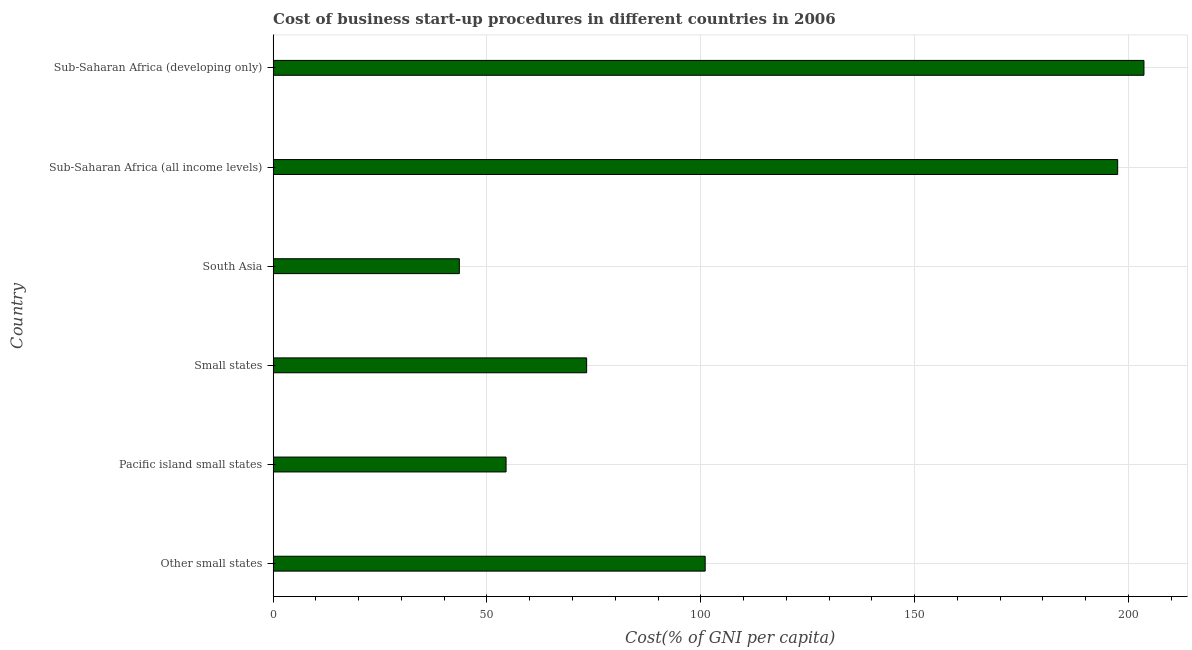Does the graph contain any zero values?
Offer a very short reply. No. What is the title of the graph?
Provide a succinct answer. Cost of business start-up procedures in different countries in 2006. What is the label or title of the X-axis?
Keep it short and to the point. Cost(% of GNI per capita). What is the label or title of the Y-axis?
Your answer should be very brief. Country. What is the cost of business startup procedures in Sub-Saharan Africa (all income levels)?
Your response must be concise. 197.47. Across all countries, what is the maximum cost of business startup procedures?
Give a very brief answer. 203.61. Across all countries, what is the minimum cost of business startup procedures?
Your answer should be compact. 43.54. In which country was the cost of business startup procedures maximum?
Give a very brief answer. Sub-Saharan Africa (developing only). In which country was the cost of business startup procedures minimum?
Offer a very short reply. South Asia. What is the sum of the cost of business startup procedures?
Give a very brief answer. 673.41. What is the difference between the cost of business startup procedures in Pacific island small states and Small states?
Ensure brevity in your answer.  -18.84. What is the average cost of business startup procedures per country?
Provide a short and direct response. 112.24. What is the median cost of business startup procedures?
Give a very brief answer. 87.16. In how many countries, is the cost of business startup procedures greater than 200 %?
Provide a succinct answer. 1. What is the ratio of the cost of business startup procedures in Pacific island small states to that in Sub-Saharan Africa (developing only)?
Ensure brevity in your answer.  0.27. Is the cost of business startup procedures in Pacific island small states less than that in South Asia?
Your response must be concise. No. What is the difference between the highest and the second highest cost of business startup procedures?
Make the answer very short. 6.14. Is the sum of the cost of business startup procedures in South Asia and Sub-Saharan Africa (all income levels) greater than the maximum cost of business startup procedures across all countries?
Provide a short and direct response. Yes. What is the difference between the highest and the lowest cost of business startup procedures?
Offer a very short reply. 160.07. What is the difference between two consecutive major ticks on the X-axis?
Ensure brevity in your answer.  50. Are the values on the major ticks of X-axis written in scientific E-notation?
Provide a short and direct response. No. What is the Cost(% of GNI per capita) of Other small states?
Make the answer very short. 101.02. What is the Cost(% of GNI per capita) of Pacific island small states?
Your answer should be compact. 54.47. What is the Cost(% of GNI per capita) in Small states?
Your answer should be very brief. 73.31. What is the Cost(% of GNI per capita) in South Asia?
Offer a terse response. 43.54. What is the Cost(% of GNI per capita) in Sub-Saharan Africa (all income levels)?
Make the answer very short. 197.47. What is the Cost(% of GNI per capita) of Sub-Saharan Africa (developing only)?
Offer a terse response. 203.61. What is the difference between the Cost(% of GNI per capita) in Other small states and Pacific island small states?
Offer a very short reply. 46.56. What is the difference between the Cost(% of GNI per capita) in Other small states and Small states?
Provide a short and direct response. 27.72. What is the difference between the Cost(% of GNI per capita) in Other small states and South Asia?
Your answer should be very brief. 57.48. What is the difference between the Cost(% of GNI per capita) in Other small states and Sub-Saharan Africa (all income levels)?
Ensure brevity in your answer.  -96.45. What is the difference between the Cost(% of GNI per capita) in Other small states and Sub-Saharan Africa (developing only)?
Your answer should be very brief. -102.59. What is the difference between the Cost(% of GNI per capita) in Pacific island small states and Small states?
Provide a short and direct response. -18.84. What is the difference between the Cost(% of GNI per capita) in Pacific island small states and South Asia?
Your response must be concise. 10.93. What is the difference between the Cost(% of GNI per capita) in Pacific island small states and Sub-Saharan Africa (all income levels)?
Your answer should be compact. -143. What is the difference between the Cost(% of GNI per capita) in Pacific island small states and Sub-Saharan Africa (developing only)?
Your response must be concise. -149.14. What is the difference between the Cost(% of GNI per capita) in Small states and South Asia?
Your answer should be compact. 29.77. What is the difference between the Cost(% of GNI per capita) in Small states and Sub-Saharan Africa (all income levels)?
Make the answer very short. -124.16. What is the difference between the Cost(% of GNI per capita) in Small states and Sub-Saharan Africa (developing only)?
Offer a very short reply. -130.31. What is the difference between the Cost(% of GNI per capita) in South Asia and Sub-Saharan Africa (all income levels)?
Give a very brief answer. -153.93. What is the difference between the Cost(% of GNI per capita) in South Asia and Sub-Saharan Africa (developing only)?
Keep it short and to the point. -160.07. What is the difference between the Cost(% of GNI per capita) in Sub-Saharan Africa (all income levels) and Sub-Saharan Africa (developing only)?
Give a very brief answer. -6.14. What is the ratio of the Cost(% of GNI per capita) in Other small states to that in Pacific island small states?
Your answer should be compact. 1.85. What is the ratio of the Cost(% of GNI per capita) in Other small states to that in Small states?
Give a very brief answer. 1.38. What is the ratio of the Cost(% of GNI per capita) in Other small states to that in South Asia?
Your answer should be very brief. 2.32. What is the ratio of the Cost(% of GNI per capita) in Other small states to that in Sub-Saharan Africa (all income levels)?
Give a very brief answer. 0.51. What is the ratio of the Cost(% of GNI per capita) in Other small states to that in Sub-Saharan Africa (developing only)?
Offer a very short reply. 0.5. What is the ratio of the Cost(% of GNI per capita) in Pacific island small states to that in Small states?
Provide a short and direct response. 0.74. What is the ratio of the Cost(% of GNI per capita) in Pacific island small states to that in South Asia?
Keep it short and to the point. 1.25. What is the ratio of the Cost(% of GNI per capita) in Pacific island small states to that in Sub-Saharan Africa (all income levels)?
Provide a succinct answer. 0.28. What is the ratio of the Cost(% of GNI per capita) in Pacific island small states to that in Sub-Saharan Africa (developing only)?
Offer a terse response. 0.27. What is the ratio of the Cost(% of GNI per capita) in Small states to that in South Asia?
Offer a terse response. 1.68. What is the ratio of the Cost(% of GNI per capita) in Small states to that in Sub-Saharan Africa (all income levels)?
Ensure brevity in your answer.  0.37. What is the ratio of the Cost(% of GNI per capita) in Small states to that in Sub-Saharan Africa (developing only)?
Offer a terse response. 0.36. What is the ratio of the Cost(% of GNI per capita) in South Asia to that in Sub-Saharan Africa (all income levels)?
Make the answer very short. 0.22. What is the ratio of the Cost(% of GNI per capita) in South Asia to that in Sub-Saharan Africa (developing only)?
Offer a very short reply. 0.21. 